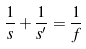Convert formula to latex. <formula><loc_0><loc_0><loc_500><loc_500>\frac { 1 } { s } + \frac { 1 } { s ^ { \prime } } = \frac { 1 } { f }</formula> 